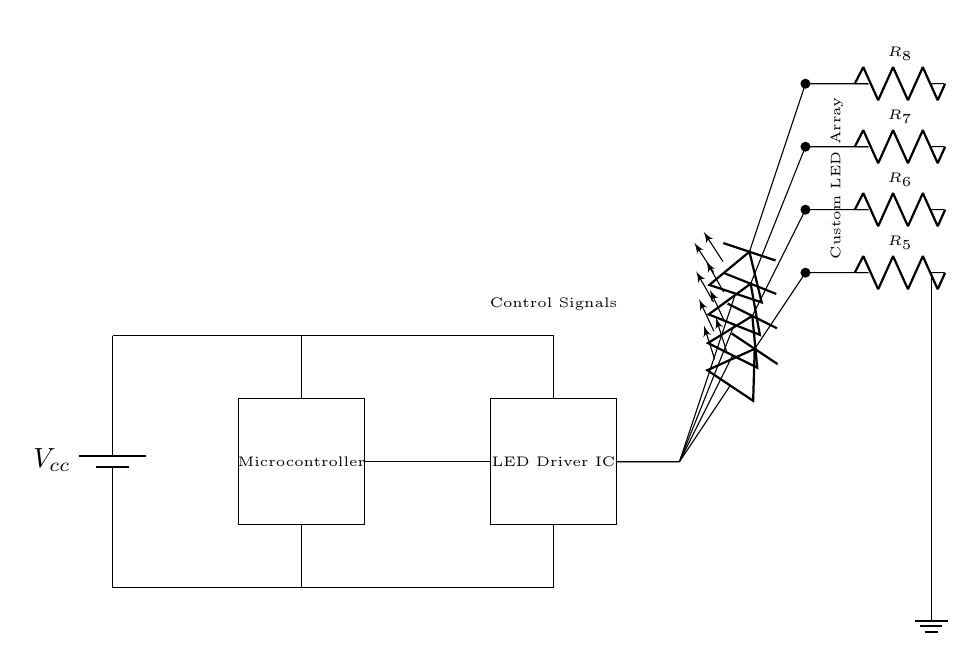What is the power supply voltage in this circuit? The power supply voltage is labeled as Vcc, which typically represents the voltage provided to the circuit. In the absence of a specific value in the diagram, it can be assumed to be a standard voltage.
Answer: Vcc What component is used to drive the LEDs? The component responsible for driving the LEDs is labeled as LED Driver IC in the diagram. This integrated circuit is designed to control the brightness and effects of the connected LEDs.
Answer: LED Driver IC How many LEDs are present in the custom LED array? There are four LEDs represented in the circuit diagram, indicated by the placements in the vertical arrangement connected to the output of the LED Driver IC.
Answer: Four What type of connection is used for the LEDs? The connections for the LEDs are made using series connections, where each LED is connected in a sequence followed by a resistor, which allows for current regulation.
Answer: Series connections What is the purpose of the resistors in the circuit? The resistors are used to limit the current flowing through the LEDs to prevent them from drawing too much current, which could lead to damage or reduced lifespan.
Answer: Current limiting What type of controller is used in this circuit? The type of controller used is a Microcontroller, which can be programmed to control the LED driver signals based on user input or predefined effects in the gaming controller.
Answer: Microcontroller What do the control signals do in this circuit? The control signals sent to the LED Driver IC regulate the operation of the LEDs, allowing for custom lighting effects to be programmed according to the input commands received.
Answer: Regulate LED operation 